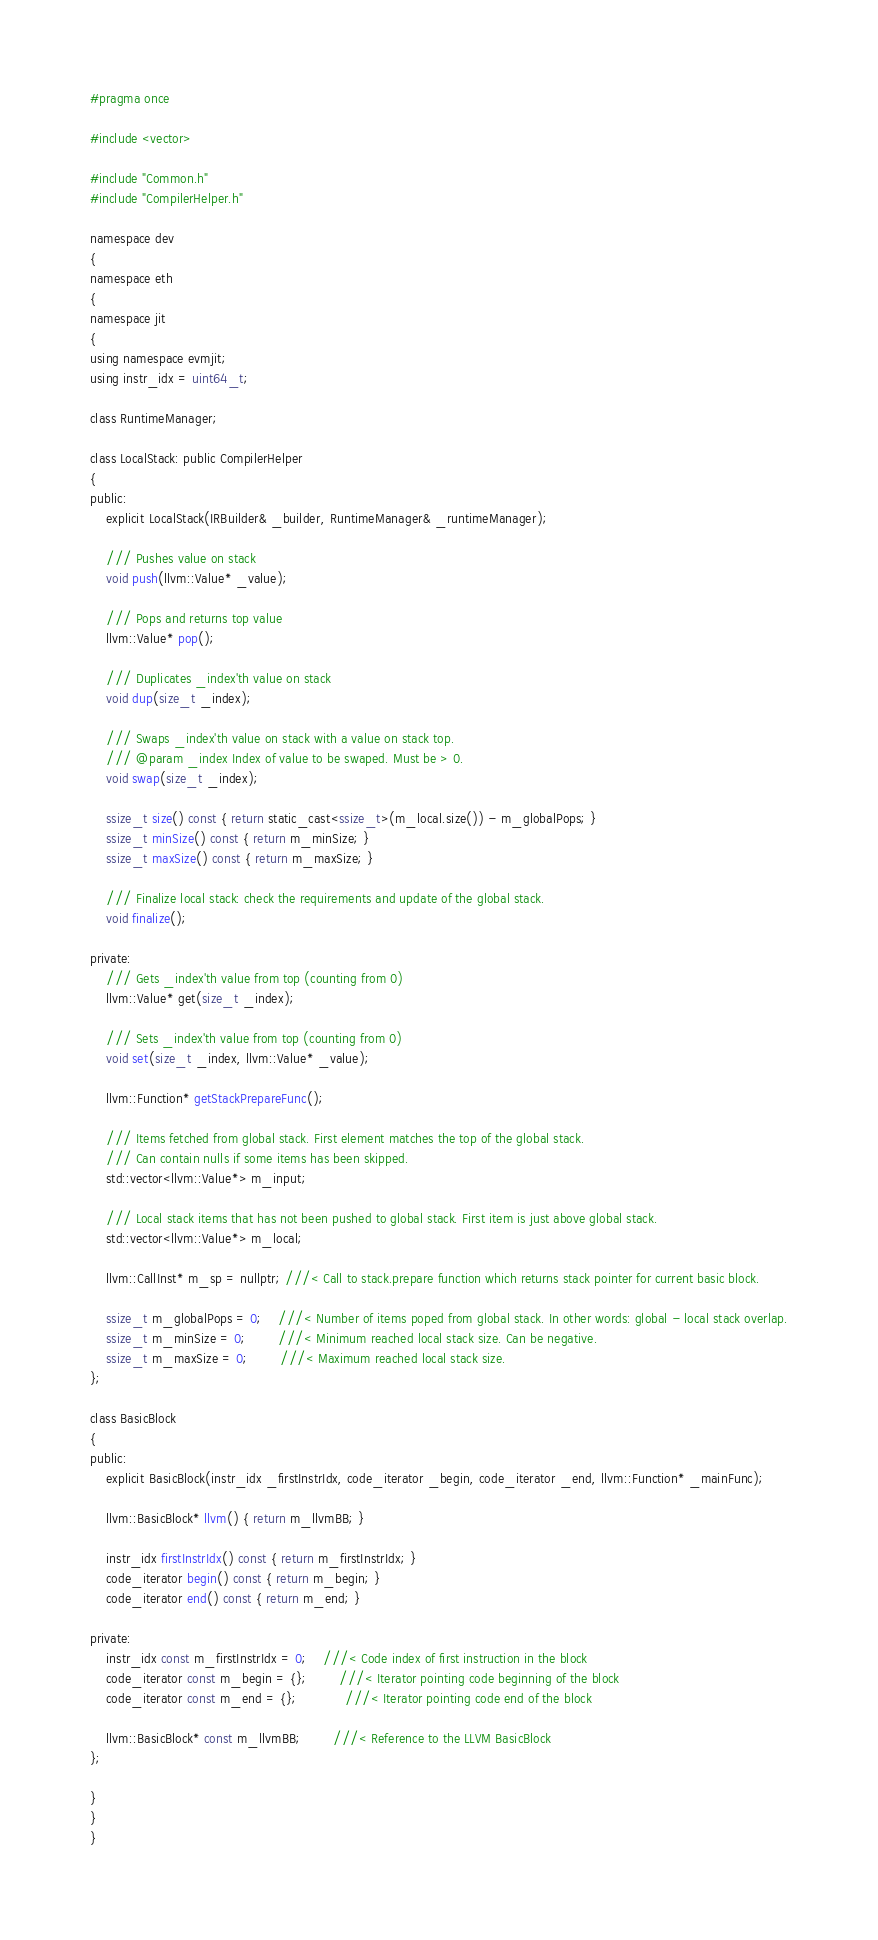Convert code to text. <code><loc_0><loc_0><loc_500><loc_500><_C_>#pragma once

#include <vector>

#include "Common.h"
#include "CompilerHelper.h"

namespace dev
{
namespace eth
{
namespace jit
{
using namespace evmjit;
using instr_idx = uint64_t;

class RuntimeManager;

class LocalStack: public CompilerHelper
{
public:
	explicit LocalStack(IRBuilder& _builder, RuntimeManager& _runtimeManager);

	/// Pushes value on stack
	void push(llvm::Value* _value);

	/// Pops and returns top value
	llvm::Value* pop();

	/// Duplicates _index'th value on stack
	void dup(size_t _index);

	/// Swaps _index'th value on stack with a value on stack top.
	/// @param _index Index of value to be swaped. Must be > 0.
	void swap(size_t _index);

	ssize_t size() const { return static_cast<ssize_t>(m_local.size()) - m_globalPops; }
	ssize_t minSize() const { return m_minSize; }
	ssize_t maxSize() const { return m_maxSize; }

	/// Finalize local stack: check the requirements and update of the global stack.
	void finalize();

private:
	/// Gets _index'th value from top (counting from 0)
	llvm::Value* get(size_t _index);

	/// Sets _index'th value from top (counting from 0)
	void set(size_t _index, llvm::Value* _value);

	llvm::Function* getStackPrepareFunc();

	/// Items fetched from global stack. First element matches the top of the global stack.
	/// Can contain nulls if some items has been skipped.
	std::vector<llvm::Value*> m_input;

	/// Local stack items that has not been pushed to global stack. First item is just above global stack.
	std::vector<llvm::Value*> m_local;

	llvm::CallInst* m_sp = nullptr; ///< Call to stack.prepare function which returns stack pointer for current basic block.

	ssize_t m_globalPops = 0; 	///< Number of items poped from global stack. In other words: global - local stack overlap.
	ssize_t m_minSize = 0;		///< Minimum reached local stack size. Can be negative.
	ssize_t m_maxSize = 0;		///< Maximum reached local stack size.
};

class BasicBlock
{
public:
	explicit BasicBlock(instr_idx _firstInstrIdx, code_iterator _begin, code_iterator _end, llvm::Function* _mainFunc);

	llvm::BasicBlock* llvm() { return m_llvmBB; }

	instr_idx firstInstrIdx() const { return m_firstInstrIdx; }
	code_iterator begin() const { return m_begin; }
	code_iterator end() const { return m_end; }

private:
	instr_idx const m_firstInstrIdx = 0; 	///< Code index of first instruction in the block
	code_iterator const m_begin = {};		///< Iterator pointing code beginning of the block
	code_iterator const m_end = {};			///< Iterator pointing code end of the block

	llvm::BasicBlock* const m_llvmBB;		///< Reference to the LLVM BasicBlock
};

}
}
}
</code> 